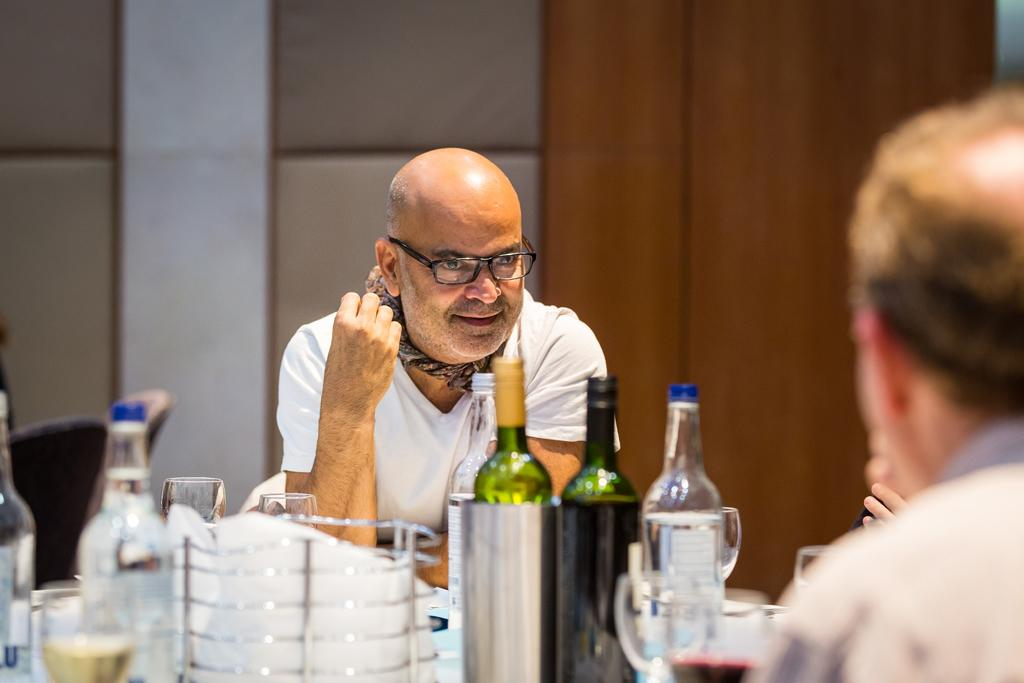How many people are sitting in the scene? There are two persons sitting on chairs. What objects can be seen on the table? There is a bottle and a glass on the table. What is located at the back side of the scene? There is a wall at the back side of the scene. What type of wire can be seen connecting the two persons in the image? There is no wire connecting the two persons in the image. Can you see a rabbit hopping around in the scene? There is no rabbit present in the image. 